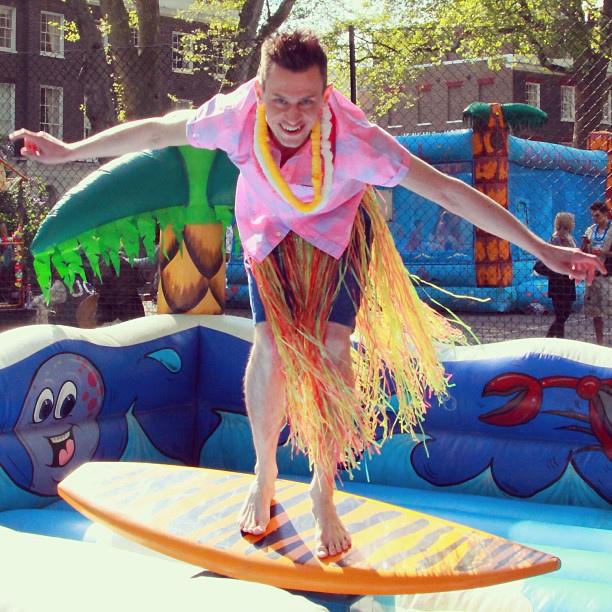What is the child standing on?
Quick response, please. Surfboard. Is he in a kiddie pool?
Give a very brief answer. Yes. What is the person wearing?
Short answer required. Grass skirt. 